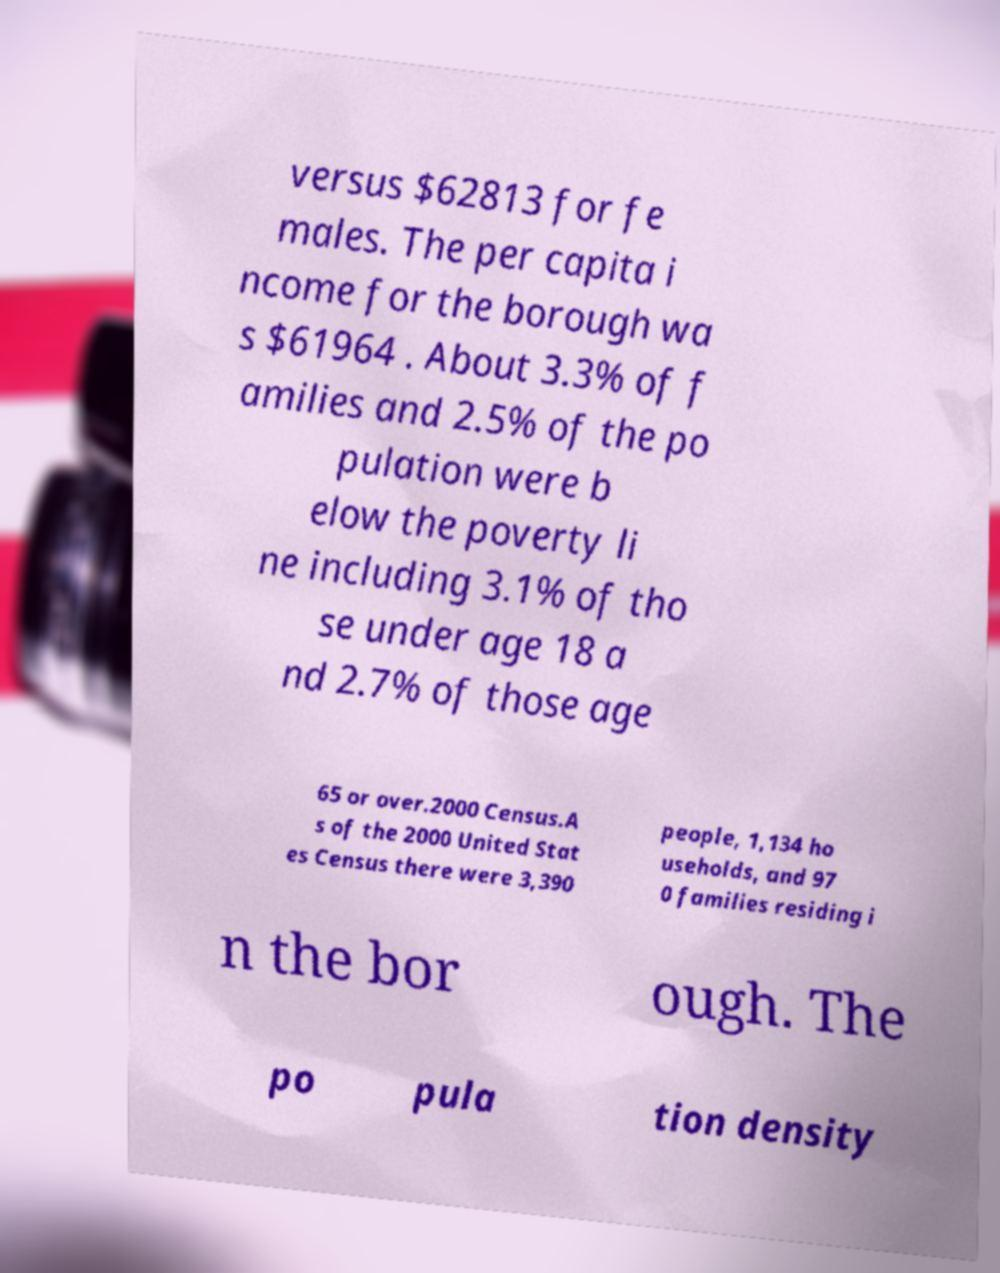Could you assist in decoding the text presented in this image and type it out clearly? versus $62813 for fe males. The per capita i ncome for the borough wa s $61964 . About 3.3% of f amilies and 2.5% of the po pulation were b elow the poverty li ne including 3.1% of tho se under age 18 a nd 2.7% of those age 65 or over.2000 Census.A s of the 2000 United Stat es Census there were 3,390 people, 1,134 ho useholds, and 97 0 families residing i n the bor ough. The po pula tion density 